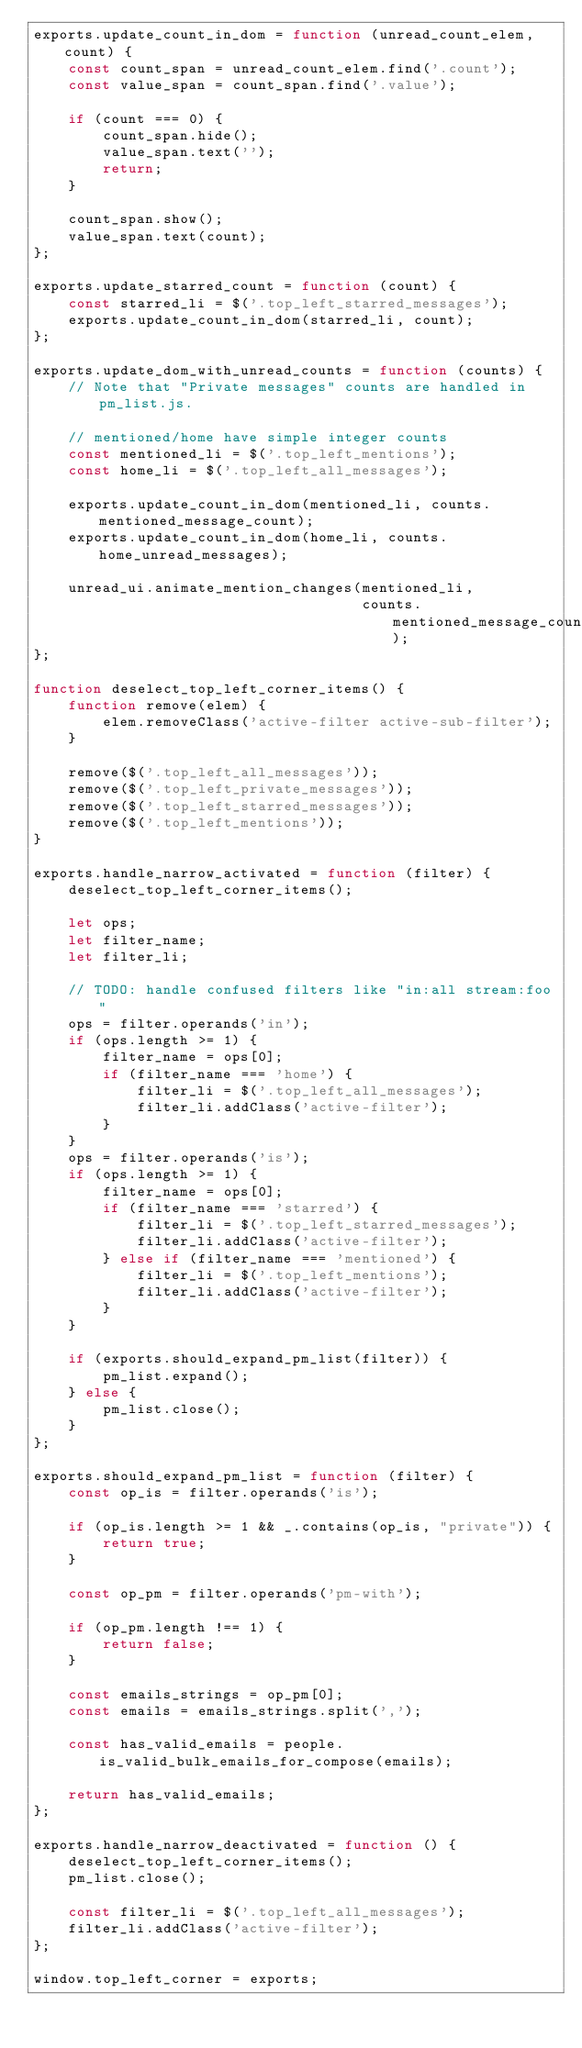<code> <loc_0><loc_0><loc_500><loc_500><_JavaScript_>exports.update_count_in_dom = function (unread_count_elem, count) {
    const count_span = unread_count_elem.find('.count');
    const value_span = count_span.find('.value');

    if (count === 0) {
        count_span.hide();
        value_span.text('');
        return;
    }

    count_span.show();
    value_span.text(count);
};

exports.update_starred_count = function (count) {
    const starred_li = $('.top_left_starred_messages');
    exports.update_count_in_dom(starred_li, count);
};

exports.update_dom_with_unread_counts = function (counts) {
    // Note that "Private messages" counts are handled in pm_list.js.

    // mentioned/home have simple integer counts
    const mentioned_li = $('.top_left_mentions');
    const home_li = $('.top_left_all_messages');

    exports.update_count_in_dom(mentioned_li, counts.mentioned_message_count);
    exports.update_count_in_dom(home_li, counts.home_unread_messages);

    unread_ui.animate_mention_changes(mentioned_li,
                                      counts.mentioned_message_count);
};

function deselect_top_left_corner_items() {
    function remove(elem) {
        elem.removeClass('active-filter active-sub-filter');
    }

    remove($('.top_left_all_messages'));
    remove($('.top_left_private_messages'));
    remove($('.top_left_starred_messages'));
    remove($('.top_left_mentions'));
}

exports.handle_narrow_activated = function (filter) {
    deselect_top_left_corner_items();

    let ops;
    let filter_name;
    let filter_li;

    // TODO: handle confused filters like "in:all stream:foo"
    ops = filter.operands('in');
    if (ops.length >= 1) {
        filter_name = ops[0];
        if (filter_name === 'home') {
            filter_li = $('.top_left_all_messages');
            filter_li.addClass('active-filter');
        }
    }
    ops = filter.operands('is');
    if (ops.length >= 1) {
        filter_name = ops[0];
        if (filter_name === 'starred') {
            filter_li = $('.top_left_starred_messages');
            filter_li.addClass('active-filter');
        } else if (filter_name === 'mentioned') {
            filter_li = $('.top_left_mentions');
            filter_li.addClass('active-filter');
        }
    }

    if (exports.should_expand_pm_list(filter)) {
        pm_list.expand();
    } else {
        pm_list.close();
    }
};

exports.should_expand_pm_list = function (filter) {
    const op_is = filter.operands('is');

    if (op_is.length >= 1 && _.contains(op_is, "private")) {
        return true;
    }

    const op_pm = filter.operands('pm-with');

    if (op_pm.length !== 1) {
        return false;
    }

    const emails_strings = op_pm[0];
    const emails = emails_strings.split(',');

    const has_valid_emails = people.is_valid_bulk_emails_for_compose(emails);

    return has_valid_emails;
};

exports.handle_narrow_deactivated = function () {
    deselect_top_left_corner_items();
    pm_list.close();

    const filter_li = $('.top_left_all_messages');
    filter_li.addClass('active-filter');
};

window.top_left_corner = exports;
</code> 